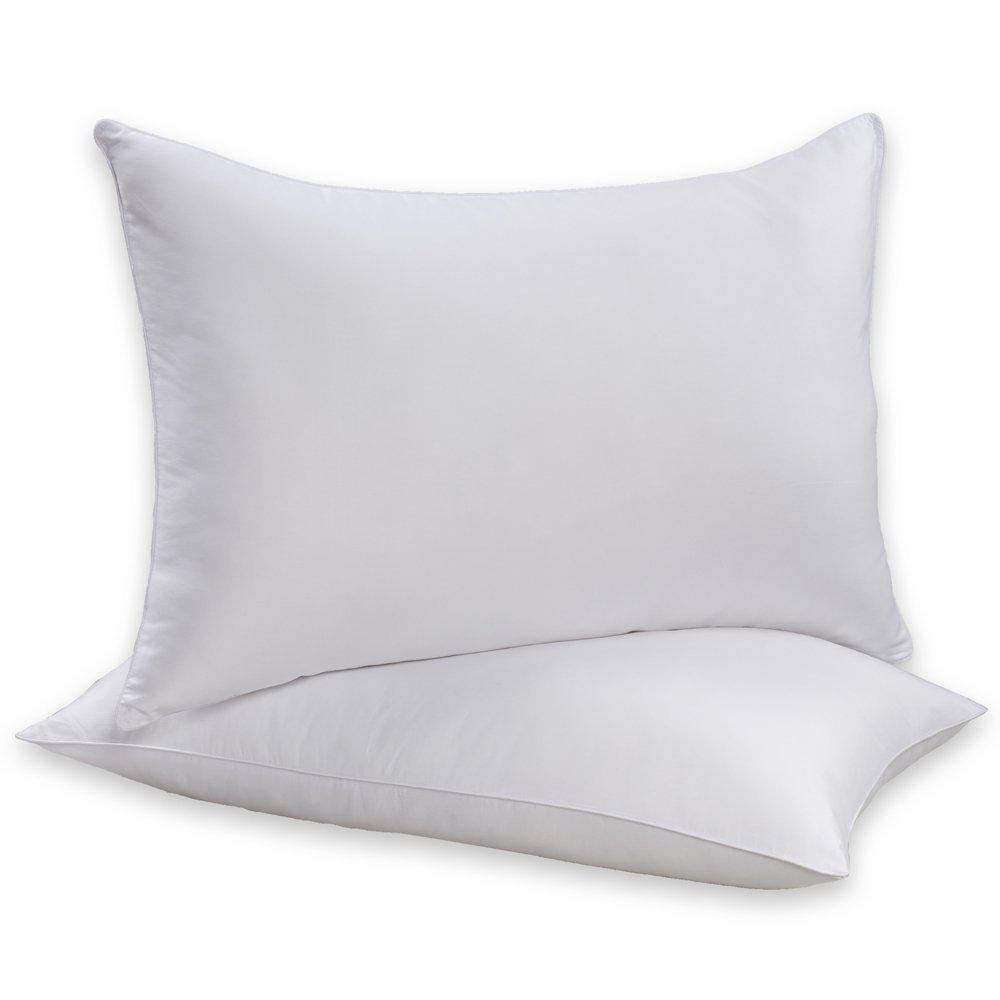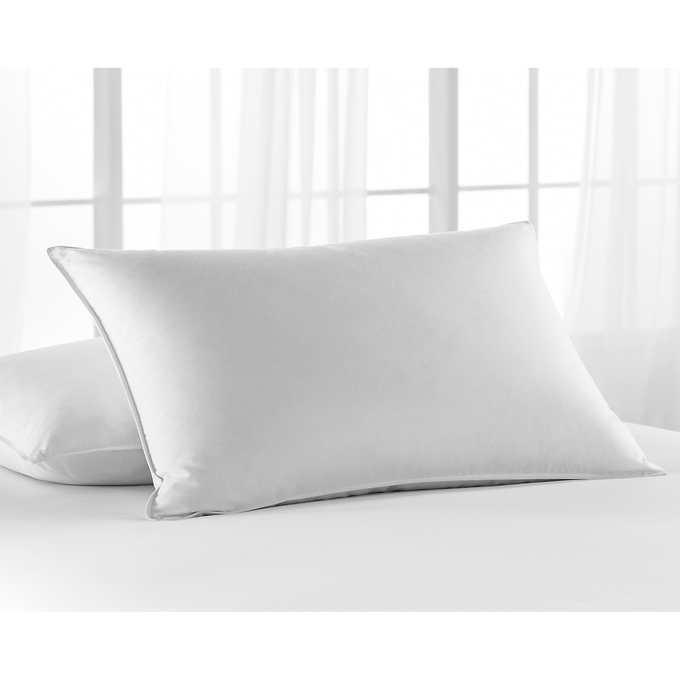The first image is the image on the left, the second image is the image on the right. Considering the images on both sides, is "Each image contains two pillows, and all pillows are rectangular rather than square." valid? Answer yes or no. Yes. The first image is the image on the left, the second image is the image on the right. Evaluate the accuracy of this statement regarding the images: "One of the images has fewer than two pillows.". Is it true? Answer yes or no. No. 